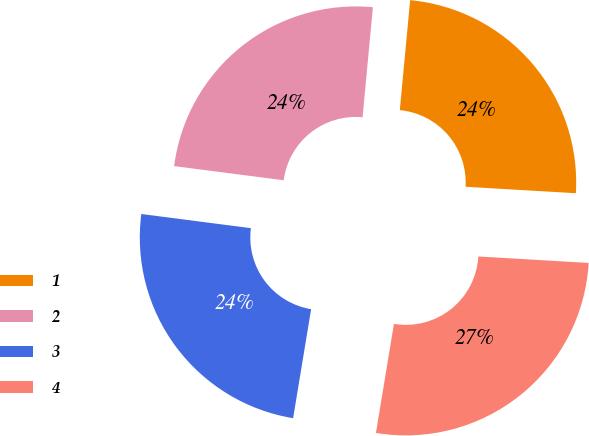Convert chart to OTSL. <chart><loc_0><loc_0><loc_500><loc_500><pie_chart><fcel>1<fcel>2<fcel>3<fcel>4<nl><fcel>24.44%<fcel>24.44%<fcel>24.44%<fcel>26.67%<nl></chart> 